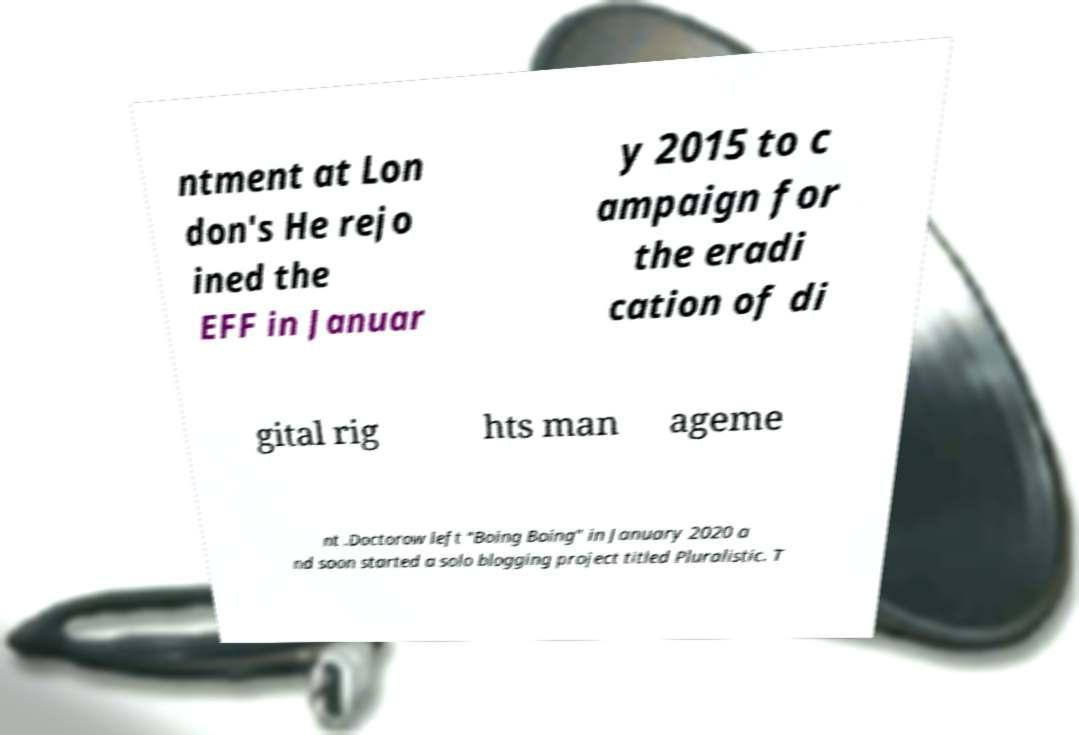Could you extract and type out the text from this image? ntment at Lon don's He rejo ined the EFF in Januar y 2015 to c ampaign for the eradi cation of di gital rig hts man ageme nt .Doctorow left "Boing Boing" in January 2020 a nd soon started a solo blogging project titled Pluralistic. T 